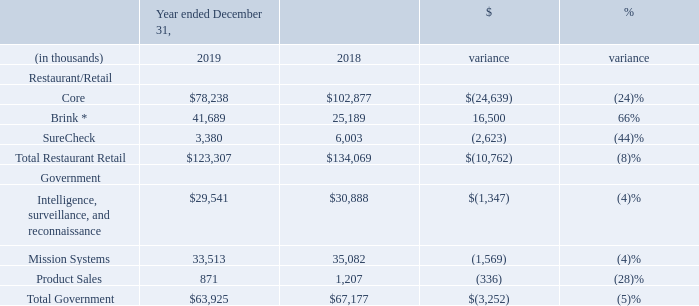Results of Operations for the Years Ended December 31, 2019 and December 31, 2018
We reported revenues of $187.2 million for the year ended December 31, 2019, down 7.0% from $201.2 million for the year ended December 31, 2018. Our net loss was $15.6 million or $0.96 loss per diluted share for the year ended December 31, 2019 versus a net loss of $24.1 million or $1.50 loss per diluted share for the year ended December 31, 2018. Our year-over-year unfavorable performance was primarily driven by lower Restaurant/Retail hardware revenue and corresponding hardware support service revenue from our traditional tier 1 customers as one of these customers completed significant projects in 2018 which were not repeated in 2019. The Company partially offset these reductions with continued growth in Brink POS revenue, including related SaaS, hardware and support services. The 2018 net loss include a valuation allowance of $14.9 million to reduce the carrying value of our deferred tax assets.
Operating segment revenue is set forth below:
* Brink includes $0.3 million of Restaurant Magic for 2019
Product revenues were $66.3 million for the year ended December 31, 2019, a decrease of 15.8% from $78.8 million recorded in 2018. This decrease was primarily driven by lower revenues from our tier 1 customers and by a decrease in our international business. Our hardware sales in the Restaurant/Retail reporting segment were down versus prior year as we completed hardware project installations with a large domestic customer during the first half of 2018 which was not recurring in 2019. Additionally, international sales were down in 2019 and SureCheck was divested. SureCheck product revenue was $0.7 million in 2019 versus $2.0 million in 2018.
Service revenues were $57.0 million for the year ended December 31, 2019, an increase of 3.1% from $55.3 million reported for the year ended December 31, 2018, primarily due to an increase in Brink, including a $3.9 million increase in Brink POS SaaS revenue more than offsetting a reduction in Services to our traditional Tier 1 customers and SureCheck Services. Surecheck Service revenue was $2.7 million in 2019 versus $4.0 million in 2018.
Contract revenues were $63.9 million for the year ended December 31, 2019, compared to $67.2 million reported for the year ended December 31, 2018, a decrease of 4.8%. This decrease was driven by a 4% decrease in our Mission Systems revenue due to reduction of revenue on cost-based contracts and a 4% reduction in ISR revenues due to ceiling limitations in a large customer's funding.
Product margins for the year ended December 31, 2019, were 22.9%, in line with the 23.0% for the year ended December 31, 2018.
Service margins were 30.9% for the year ended December 31, 2019, an increase from 23.8% recorded for the year ended December 31,2018. ServicemarginsincreasedprimarilyduetoBrinkPOSSaaSandtheincreaseinprofitabilityinourfieldservicebusiness. During 2018 and 2019, impairment charges were recorded for SureCheck capitalized software of $1.6 million and $0.7 million, respectively.
Contract margins were 8.9% for the year ended December 31, 2019, compared to 10.7% for the year ended December 31, 2018. The decrease in margin was primarily driven by decrease activity in Mission Systems' better performing cost-based contracts.
Selling, general, and administrative expenses were $37.0 million for the year ending December 31, 2019, compared to $35.0 million for the year ended December 31, 2018. The increase is due to additional investments in Brink POS sales and marketing and increased equity and incentive compensation, partially offset by savings in other departments. SG&A expenses associated with the internal investigation for 2019 were $0.6 million as compared to $1.1M in 2018.
Research and development expenses were $13.4 million for the year ended December 31, 2019, compared to $12.4 million recorded for the year ended December 31, 2018. This increase was primarily related to a $2.1 million increase in software development investments for Brink offset by decreases in other product lines.
During the year ended December 31, 2019, we recorded $1.2 million of amortization expense associated with acquired identifiable intangible assets in connection with our acquisition of Brink Software, Inc. in September 2014 (the "Brink Acquisition") compared to $1.0 million for the year ended December 31, 2018. Additionally, in 2019 we recorded $0.2 million of amortization expense associated with acquired identifiable intangible assets in the Drive-Thru Acquisition, and $0.1 million of amortization expense associated with acquired identifiable intangible assets in the Restaurant Magic Acquisition.
Other (expense) income, net, was ($1.5 million) for the year ended December 31, 2019, as compared to other income, net of $0.3 million for the year ended December 31, 2018. Other income/expense primarily includes fair value adjustments on contingent considerations, rental income, net of applicable expenses, foreign currency transactions gains and losses, fair value fluctuations of our deferred compensation plan and other non-operating income/expense. In 2018, a $0.5 million gain was recorded for the sale of real estate. In 2019, there was a $0.2 million expense for the termination of the Brink Acquisition earn-out agreement compared to a $0.5 million benefit as a result of a reduction of contingent consideration related to the Brink Acquisition in 2018.
Interest expense, net was $4.6 million for the year ended December 31, 2019, as compared to interest expense, net of $0.4 million for the year ended December 31, 2018. The increase reflects $2.6 million of interest expense related to the sale of the 4.50% Convertible Senior Notes due 2024 issued on April 15, 2019 (the "2024 notes") as well as $2.0 million of accretion of 2024 notes debt discount for 2019.
For the year ended December 31, 2019, our effective income tax rate was 18.9%, which was mainly due to deferred tax adjustments related to foreign tax credit carryforwards and state taxes, offset by changes in the valuation allowance and excess tax benefits resulting from the exercise of non-qualified stock options. For the year ended December 31, 2018, our effective income tax rate was (141.7)% due to recording a full valuation allowance on the entire deferred tax assets.
What was the revenue in 2019 and 2018 respectively? $187.2 million, $201.2 million. What was the revenue from Brink in 2019 and 2018 respectively?
Answer scale should be: thousand. 41,689, 25,189. What was the core revenue in 2019 and 2018 respectively?
Answer scale should be: thousand. $78,238, $102,877. What is the average Core revenue for 2018 and 2019?
Answer scale should be: thousand. (78,238 + 102,877) / 2
Answer: 90557.5. In which year was Brink revenue less than 40,000 thousands? Locate and analyze brink in row 5
answer: 2018. What percentage of total government revenue was from product sales in 2019?
Answer scale should be: percent. 871 / 63,925
Answer: 1.36. 